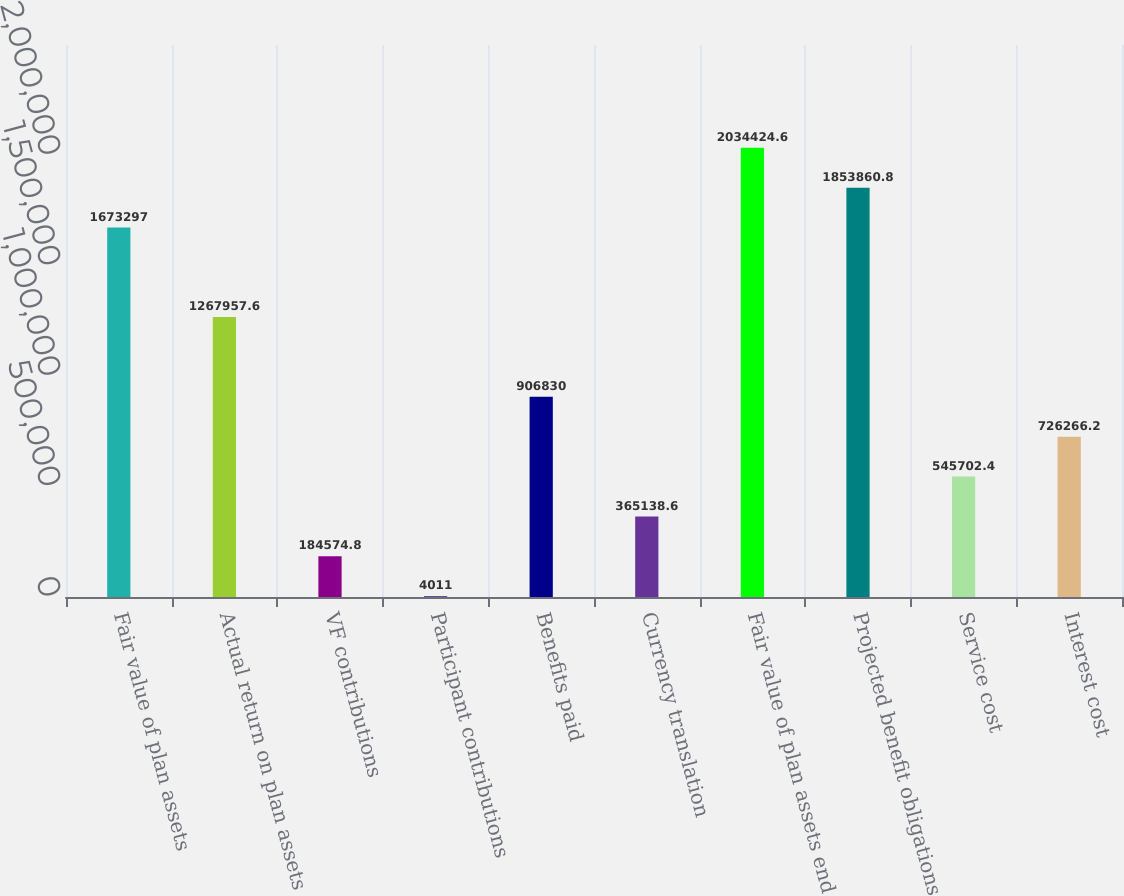Convert chart. <chart><loc_0><loc_0><loc_500><loc_500><bar_chart><fcel>Fair value of plan assets<fcel>Actual return on plan assets<fcel>VF contributions<fcel>Participant contributions<fcel>Benefits paid<fcel>Currency translation<fcel>Fair value of plan assets end<fcel>Projected benefit obligations<fcel>Service cost<fcel>Interest cost<nl><fcel>1.6733e+06<fcel>1.26796e+06<fcel>184575<fcel>4011<fcel>906830<fcel>365139<fcel>2.03442e+06<fcel>1.85386e+06<fcel>545702<fcel>726266<nl></chart> 